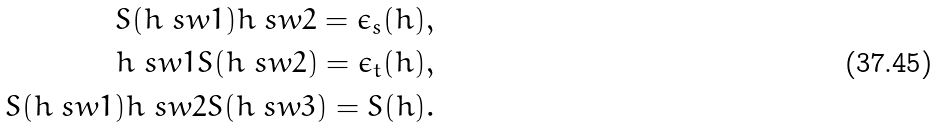<formula> <loc_0><loc_0><loc_500><loc_500>S ( h \ s w 1 ) h \ s w 2 = \epsilon _ { s } ( h ) , \\ h \ s w 1 S ( h \ s w 2 ) = \epsilon _ { t } ( h ) , \\ S ( h \ s w 1 ) h \ s w 2 S ( h \ s w 3 ) = S ( h ) .</formula> 